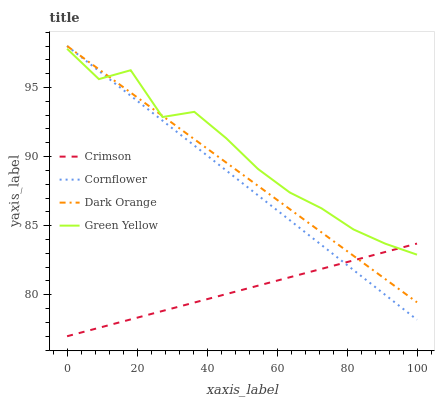Does Crimson have the minimum area under the curve?
Answer yes or no. Yes. Does Green Yellow have the maximum area under the curve?
Answer yes or no. Yes. Does Cornflower have the minimum area under the curve?
Answer yes or no. No. Does Cornflower have the maximum area under the curve?
Answer yes or no. No. Is Crimson the smoothest?
Answer yes or no. Yes. Is Green Yellow the roughest?
Answer yes or no. Yes. Is Cornflower the smoothest?
Answer yes or no. No. Is Cornflower the roughest?
Answer yes or no. No. Does Cornflower have the lowest value?
Answer yes or no. No. Does Dark Orange have the highest value?
Answer yes or no. Yes. Does Green Yellow have the highest value?
Answer yes or no. No. Does Cornflower intersect Dark Orange?
Answer yes or no. Yes. Is Cornflower less than Dark Orange?
Answer yes or no. No. Is Cornflower greater than Dark Orange?
Answer yes or no. No. 